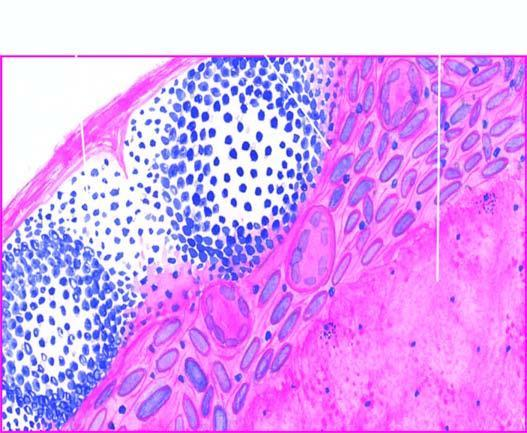does the periphery show granulomatous inflammation?
Answer the question using a single word or phrase. Yes 